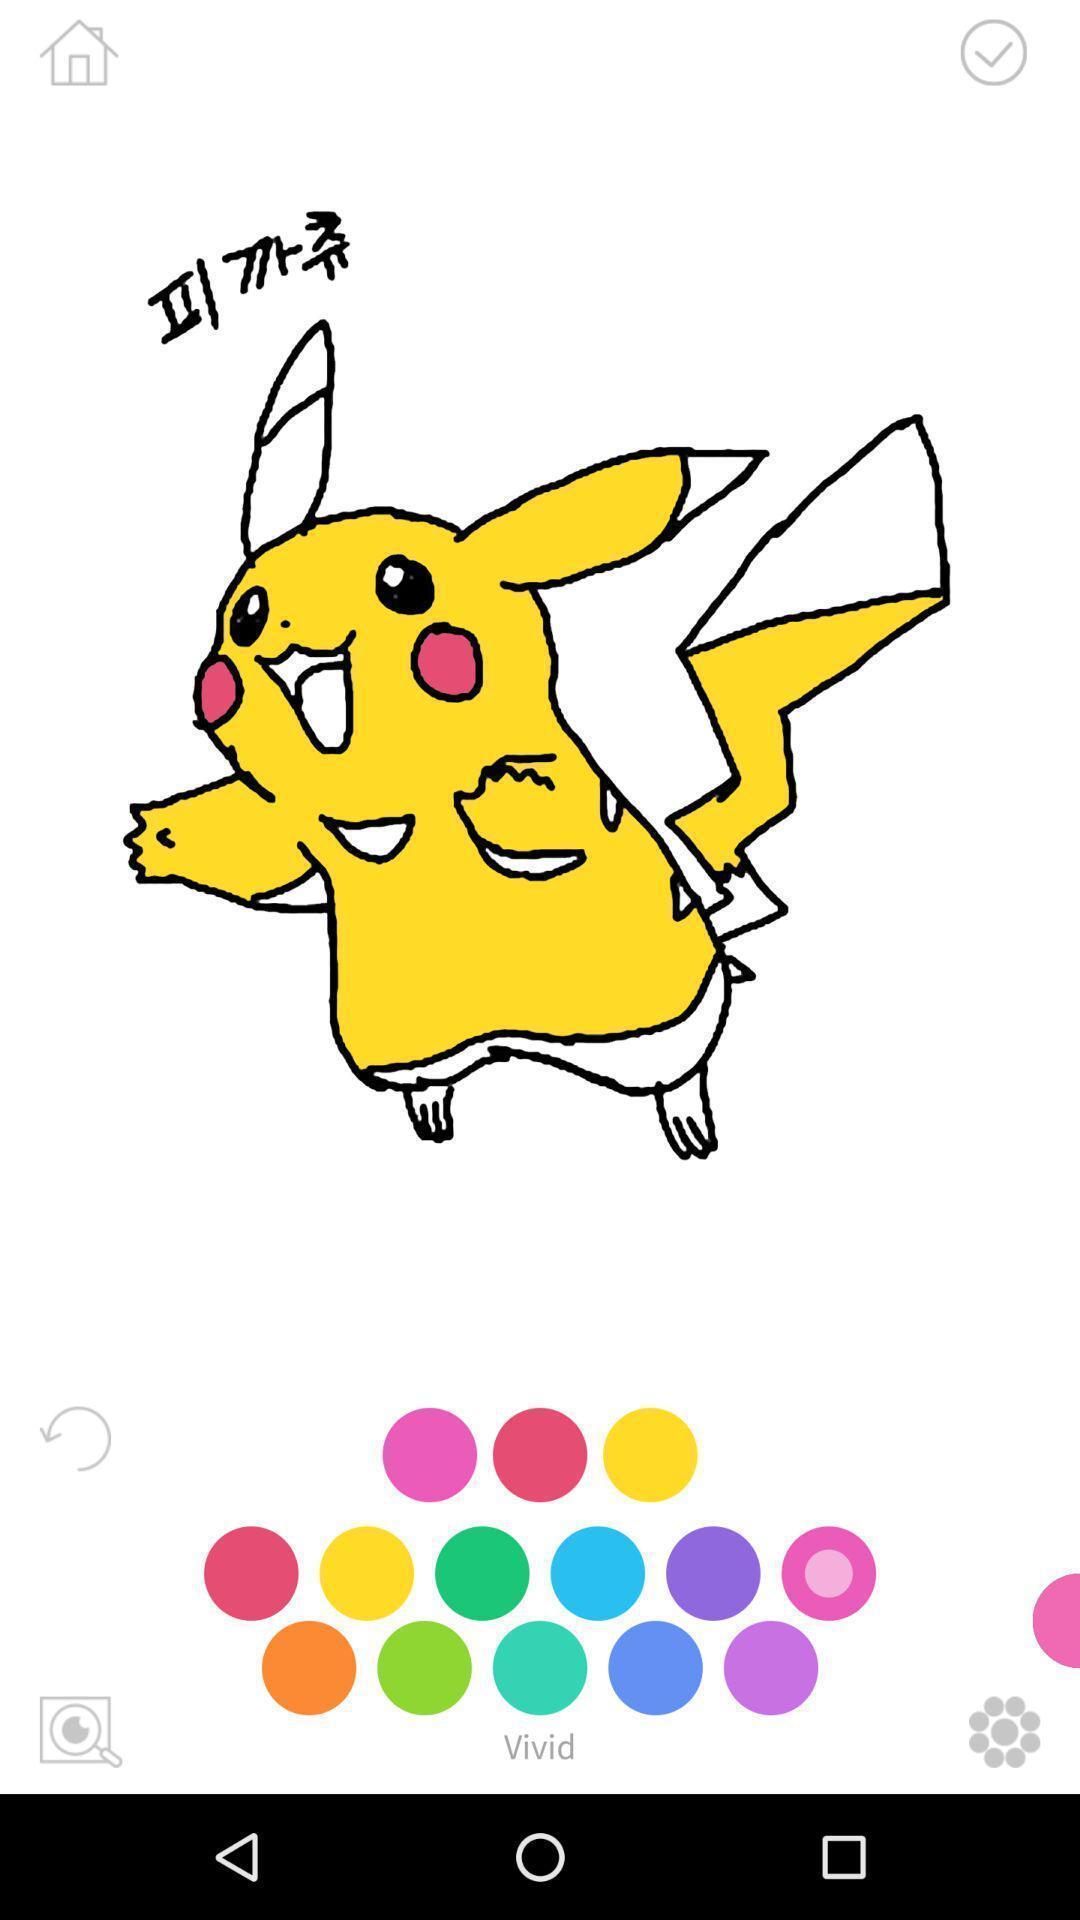Provide a description of this screenshot. Screen showing an image with colors options to color. 